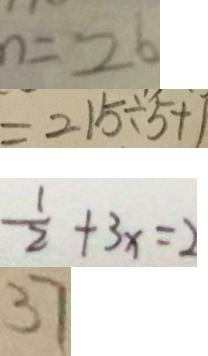Convert formula to latex. <formula><loc_0><loc_0><loc_500><loc_500>n = 2 6 
 = 2 1 5 \div 5 + 1 
 \frac { 1 } { 2 } + 3 x = 2 
 3 7</formula> 